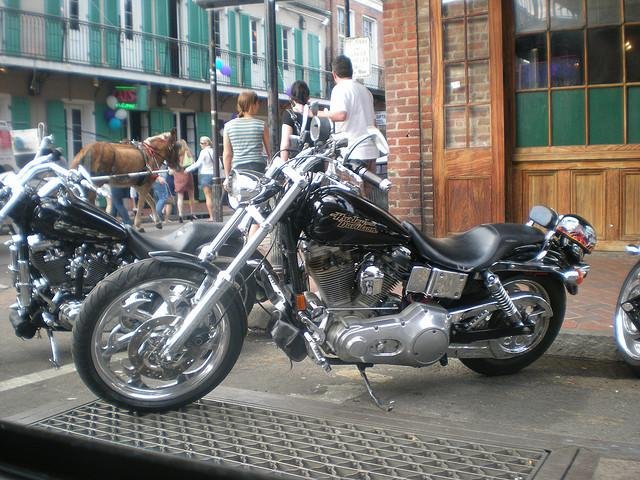What is this type of motorcycle known as? harley 